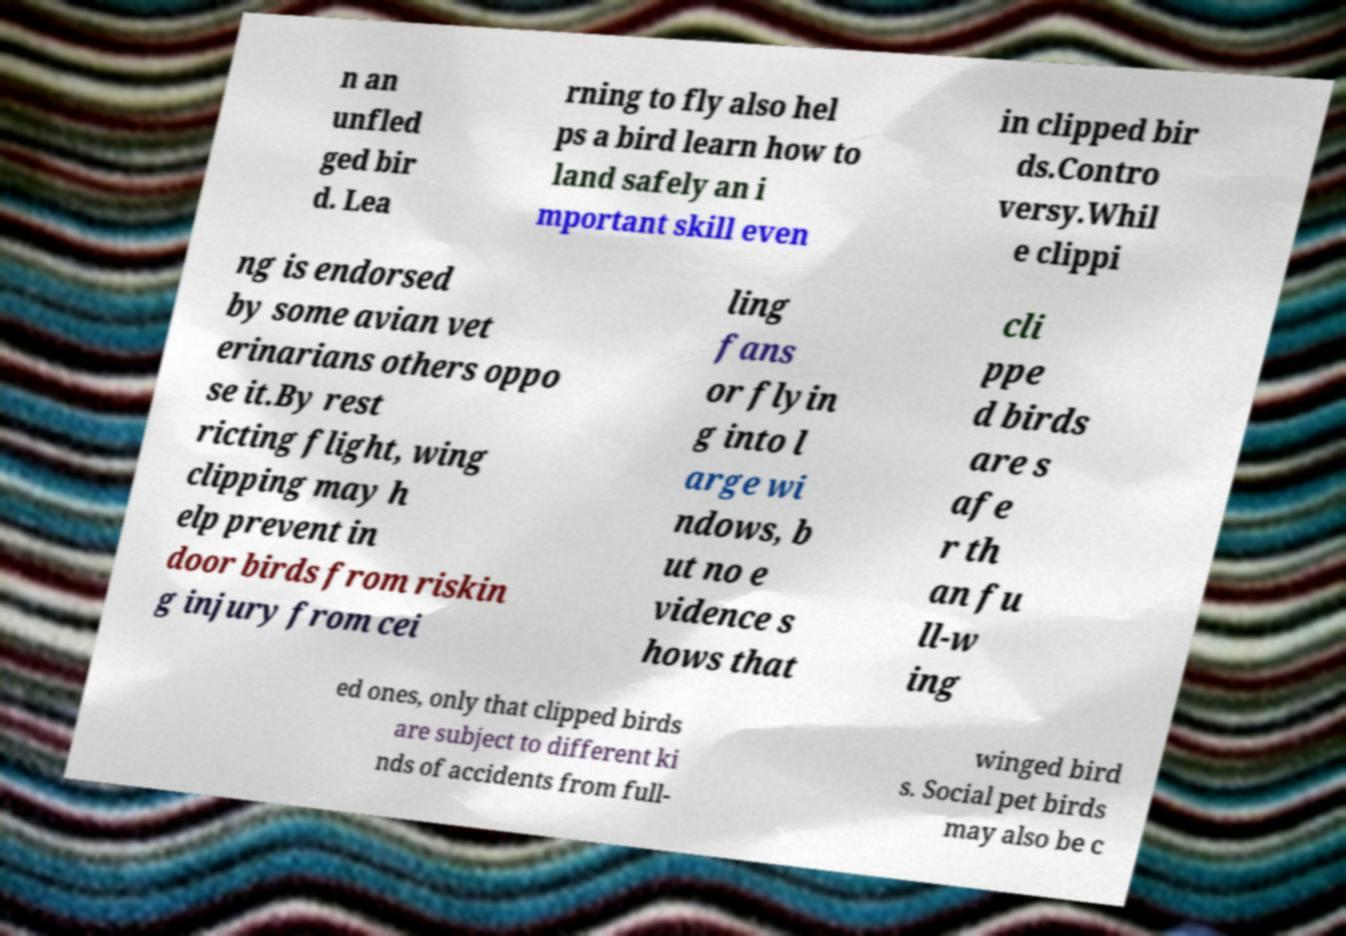Can you read and provide the text displayed in the image?This photo seems to have some interesting text. Can you extract and type it out for me? n an unfled ged bir d. Lea rning to fly also hel ps a bird learn how to land safely an i mportant skill even in clipped bir ds.Contro versy.Whil e clippi ng is endorsed by some avian vet erinarians others oppo se it.By rest ricting flight, wing clipping may h elp prevent in door birds from riskin g injury from cei ling fans or flyin g into l arge wi ndows, b ut no e vidence s hows that cli ppe d birds are s afe r th an fu ll-w ing ed ones, only that clipped birds are subject to different ki nds of accidents from full- winged bird s. Social pet birds may also be c 